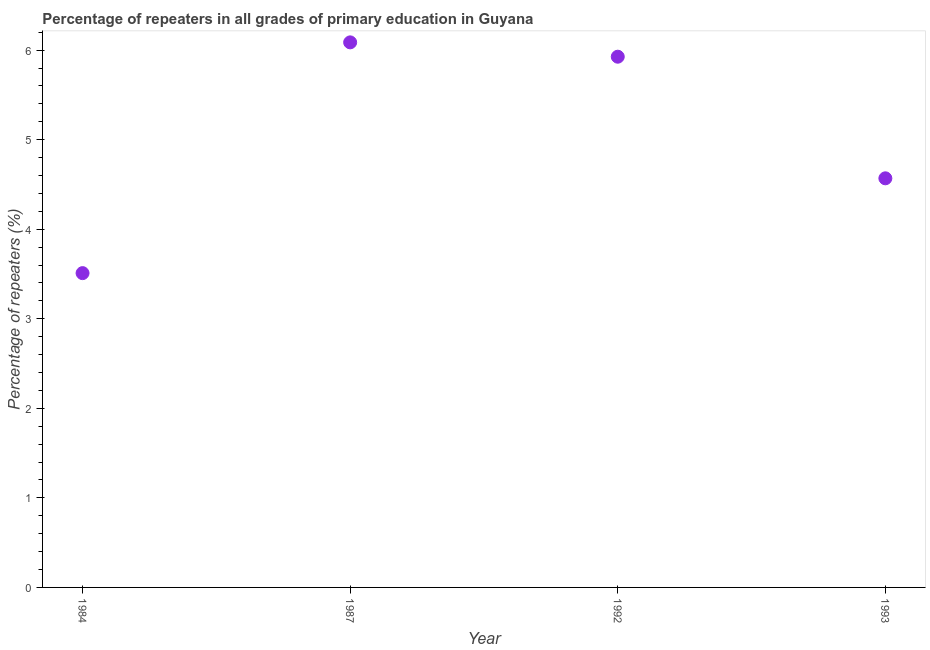What is the percentage of repeaters in primary education in 1984?
Offer a terse response. 3.51. Across all years, what is the maximum percentage of repeaters in primary education?
Give a very brief answer. 6.09. Across all years, what is the minimum percentage of repeaters in primary education?
Keep it short and to the point. 3.51. In which year was the percentage of repeaters in primary education maximum?
Offer a terse response. 1987. In which year was the percentage of repeaters in primary education minimum?
Make the answer very short. 1984. What is the sum of the percentage of repeaters in primary education?
Keep it short and to the point. 20.09. What is the difference between the percentage of repeaters in primary education in 1984 and 1987?
Provide a succinct answer. -2.58. What is the average percentage of repeaters in primary education per year?
Provide a short and direct response. 5.02. What is the median percentage of repeaters in primary education?
Provide a short and direct response. 5.25. In how many years, is the percentage of repeaters in primary education greater than 3.2 %?
Offer a very short reply. 4. Do a majority of the years between 1993 and 1987 (inclusive) have percentage of repeaters in primary education greater than 3.6 %?
Ensure brevity in your answer.  No. What is the ratio of the percentage of repeaters in primary education in 1987 to that in 1992?
Your answer should be compact. 1.03. Is the percentage of repeaters in primary education in 1987 less than that in 1992?
Provide a succinct answer. No. Is the difference between the percentage of repeaters in primary education in 1987 and 1992 greater than the difference between any two years?
Offer a very short reply. No. What is the difference between the highest and the second highest percentage of repeaters in primary education?
Provide a succinct answer. 0.16. What is the difference between the highest and the lowest percentage of repeaters in primary education?
Offer a very short reply. 2.58. In how many years, is the percentage of repeaters in primary education greater than the average percentage of repeaters in primary education taken over all years?
Give a very brief answer. 2. Does the percentage of repeaters in primary education monotonically increase over the years?
Keep it short and to the point. No. How many years are there in the graph?
Give a very brief answer. 4. Are the values on the major ticks of Y-axis written in scientific E-notation?
Provide a succinct answer. No. Does the graph contain any zero values?
Provide a short and direct response. No. What is the title of the graph?
Your answer should be very brief. Percentage of repeaters in all grades of primary education in Guyana. What is the label or title of the Y-axis?
Your answer should be very brief. Percentage of repeaters (%). What is the Percentage of repeaters (%) in 1984?
Offer a terse response. 3.51. What is the Percentage of repeaters (%) in 1987?
Offer a terse response. 6.09. What is the Percentage of repeaters (%) in 1992?
Give a very brief answer. 5.93. What is the Percentage of repeaters (%) in 1993?
Your answer should be compact. 4.57. What is the difference between the Percentage of repeaters (%) in 1984 and 1987?
Make the answer very short. -2.58. What is the difference between the Percentage of repeaters (%) in 1984 and 1992?
Your answer should be compact. -2.42. What is the difference between the Percentage of repeaters (%) in 1984 and 1993?
Offer a terse response. -1.06. What is the difference between the Percentage of repeaters (%) in 1987 and 1992?
Ensure brevity in your answer.  0.16. What is the difference between the Percentage of repeaters (%) in 1987 and 1993?
Your answer should be very brief. 1.52. What is the difference between the Percentage of repeaters (%) in 1992 and 1993?
Make the answer very short. 1.36. What is the ratio of the Percentage of repeaters (%) in 1984 to that in 1987?
Ensure brevity in your answer.  0.58. What is the ratio of the Percentage of repeaters (%) in 1984 to that in 1992?
Your answer should be compact. 0.59. What is the ratio of the Percentage of repeaters (%) in 1984 to that in 1993?
Make the answer very short. 0.77. What is the ratio of the Percentage of repeaters (%) in 1987 to that in 1993?
Keep it short and to the point. 1.33. What is the ratio of the Percentage of repeaters (%) in 1992 to that in 1993?
Your response must be concise. 1.3. 